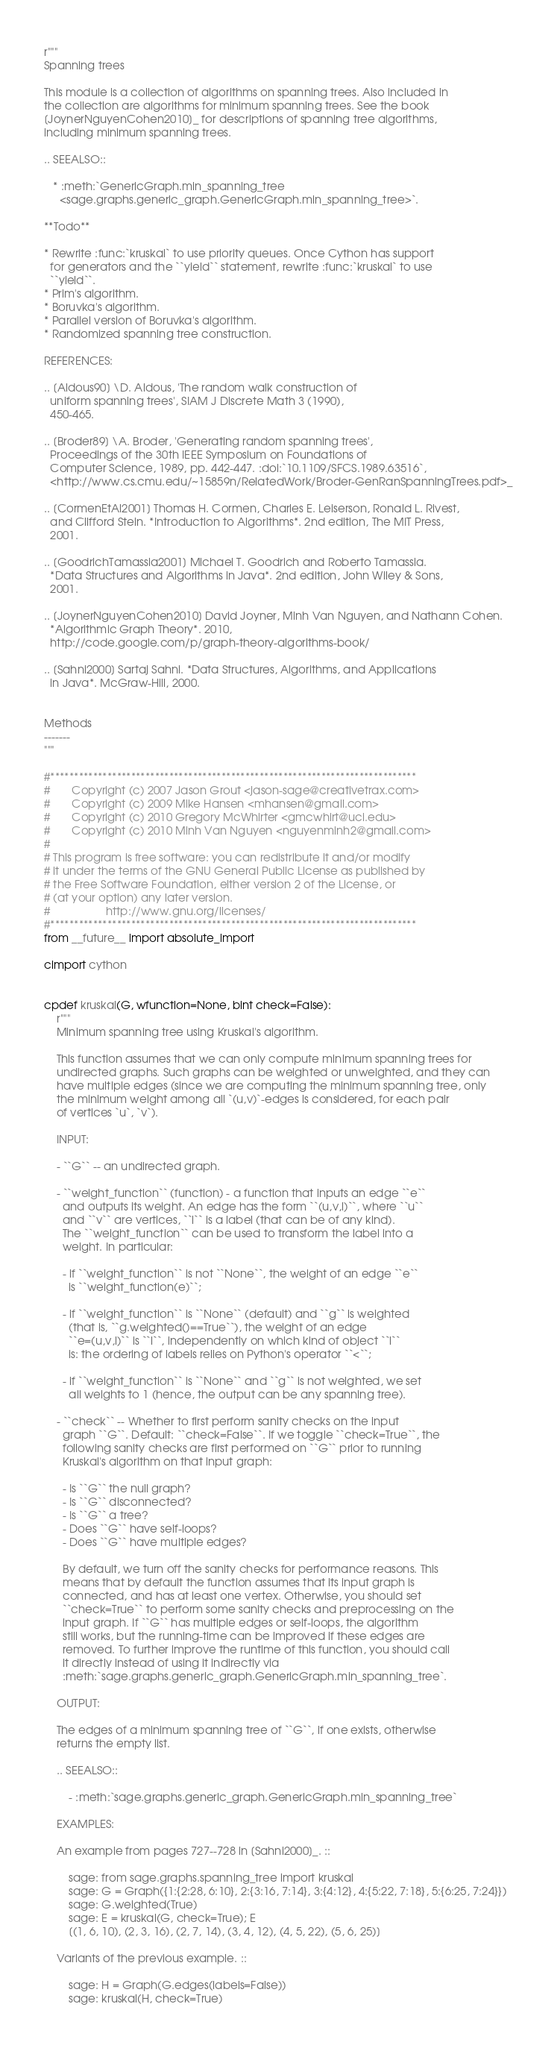<code> <loc_0><loc_0><loc_500><loc_500><_Cython_>r"""
Spanning trees

This module is a collection of algorithms on spanning trees. Also included in
the collection are algorithms for minimum spanning trees. See the book
[JoynerNguyenCohen2010]_ for descriptions of spanning tree algorithms,
including minimum spanning trees.

.. SEEALSO::

   * :meth:`GenericGraph.min_spanning_tree
     <sage.graphs.generic_graph.GenericGraph.min_spanning_tree>`.

**Todo**

* Rewrite :func:`kruskal` to use priority queues. Once Cython has support
  for generators and the ``yield`` statement, rewrite :func:`kruskal` to use
  ``yield``.
* Prim's algorithm.
* Boruvka's algorithm.
* Parallel version of Boruvka's algorithm.
* Randomized spanning tree construction.

REFERENCES:

.. [Aldous90] \D. Aldous, 'The random walk construction of
  uniform spanning trees', SIAM J Discrete Math 3 (1990),
  450-465.

.. [Broder89] \A. Broder, 'Generating random spanning trees',
  Proceedings of the 30th IEEE Symposium on Foundations of
  Computer Science, 1989, pp. 442-447. :doi:`10.1109/SFCS.1989.63516`,
  <http://www.cs.cmu.edu/~15859n/RelatedWork/Broder-GenRanSpanningTrees.pdf>_

.. [CormenEtAl2001] Thomas H. Cormen, Charles E. Leiserson, Ronald L. Rivest,
  and Clifford Stein. *Introduction to Algorithms*. 2nd edition, The MIT Press,
  2001.

.. [GoodrichTamassia2001] Michael T. Goodrich and Roberto Tamassia.
  *Data Structures and Algorithms in Java*. 2nd edition, John Wiley & Sons,
  2001.

.. [JoynerNguyenCohen2010] David Joyner, Minh Van Nguyen, and Nathann Cohen.
  *Algorithmic Graph Theory*. 2010,
  http://code.google.com/p/graph-theory-algorithms-book/

.. [Sahni2000] Sartaj Sahni. *Data Structures, Algorithms, and Applications
  in Java*. McGraw-Hill, 2000.


Methods
-------
"""

#*****************************************************************************
#       Copyright (c) 2007 Jason Grout <jason-sage@creativetrax.com>
#       Copyright (c) 2009 Mike Hansen <mhansen@gmail.com>
#       Copyright (c) 2010 Gregory McWhirter <gmcwhirt@uci.edu>
#       Copyright (c) 2010 Minh Van Nguyen <nguyenminh2@gmail.com>
#
# This program is free software: you can redistribute it and/or modify
# it under the terms of the GNU General Public License as published by
# the Free Software Foundation, either version 2 of the License, or
# (at your option) any later version.
#                  http://www.gnu.org/licenses/
#*****************************************************************************
from __future__ import absolute_import

cimport cython


cpdef kruskal(G, wfunction=None, bint check=False):
    r"""
    Minimum spanning tree using Kruskal's algorithm.

    This function assumes that we can only compute minimum spanning trees for
    undirected graphs. Such graphs can be weighted or unweighted, and they can
    have multiple edges (since we are computing the minimum spanning tree, only
    the minimum weight among all `(u,v)`-edges is considered, for each pair
    of vertices `u`, `v`).

    INPUT:

    - ``G`` -- an undirected graph.

    - ``weight_function`` (function) - a function that inputs an edge ``e``
      and outputs its weight. An edge has the form ``(u,v,l)``, where ``u``
      and ``v`` are vertices, ``l`` is a label (that can be of any kind).
      The ``weight_function`` can be used to transform the label into a
      weight. In particular:

      - if ``weight_function`` is not ``None``, the weight of an edge ``e``
        is ``weight_function(e)``;

      - if ``weight_function`` is ``None`` (default) and ``g`` is weighted
        (that is, ``g.weighted()==True``), the weight of an edge
        ``e=(u,v,l)`` is ``l``, independently on which kind of object ``l``
        is: the ordering of labels relies on Python's operator ``<``;

      - if ``weight_function`` is ``None`` and ``g`` is not weighted, we set
        all weights to 1 (hence, the output can be any spanning tree).

    - ``check`` -- Whether to first perform sanity checks on the input
      graph ``G``. Default: ``check=False``. If we toggle ``check=True``, the
      following sanity checks are first performed on ``G`` prior to running
      Kruskal's algorithm on that input graph:

      - Is ``G`` the null graph?
      - Is ``G`` disconnected?
      - Is ``G`` a tree?
      - Does ``G`` have self-loops?
      - Does ``G`` have multiple edges?

      By default, we turn off the sanity checks for performance reasons. This
      means that by default the function assumes that its input graph is
      connected, and has at least one vertex. Otherwise, you should set
      ``check=True`` to perform some sanity checks and preprocessing on the
      input graph. If ``G`` has multiple edges or self-loops, the algorithm
      still works, but the running-time can be improved if these edges are
      removed. To further improve the runtime of this function, you should call
      it directly instead of using it indirectly via
      :meth:`sage.graphs.generic_graph.GenericGraph.min_spanning_tree`.

    OUTPUT:

    The edges of a minimum spanning tree of ``G``, if one exists, otherwise
    returns the empty list.

    .. SEEALSO::

        - :meth:`sage.graphs.generic_graph.GenericGraph.min_spanning_tree`

    EXAMPLES:

    An example from pages 727--728 in [Sahni2000]_. ::

        sage: from sage.graphs.spanning_tree import kruskal
        sage: G = Graph({1:{2:28, 6:10}, 2:{3:16, 7:14}, 3:{4:12}, 4:{5:22, 7:18}, 5:{6:25, 7:24}})
        sage: G.weighted(True)
        sage: E = kruskal(G, check=True); E
        [(1, 6, 10), (2, 3, 16), (2, 7, 14), (3, 4, 12), (4, 5, 22), (5, 6, 25)]

    Variants of the previous example. ::

        sage: H = Graph(G.edges(labels=False))
        sage: kruskal(H, check=True)</code> 